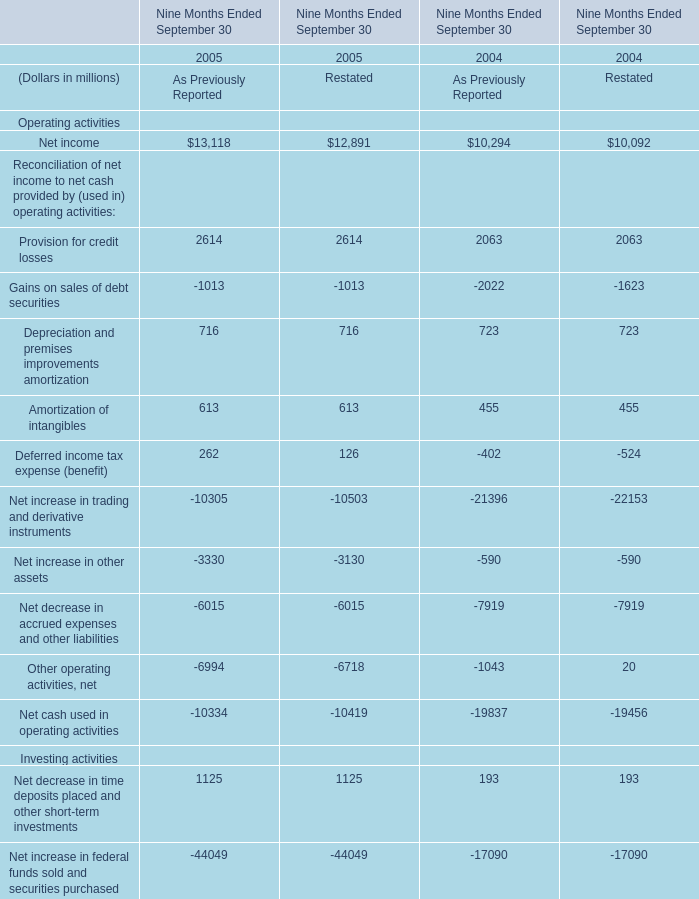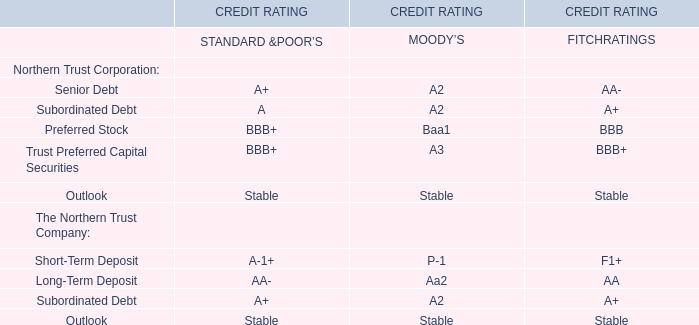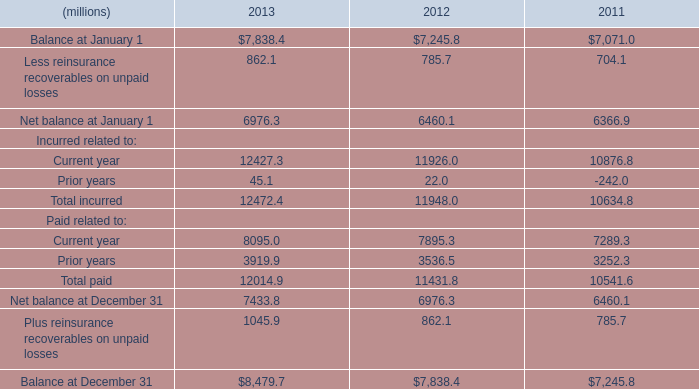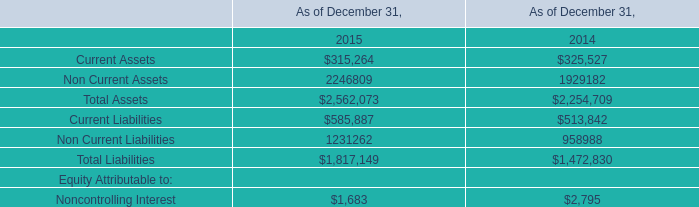In the year with lowest amount of Depreciation and premises improvements amortization, what's the increasing rate of Amortization of intangibles? 
Computations: ((((262 + 126) + 402) + 524) / (262 + 126))
Answer: 3.3866. 